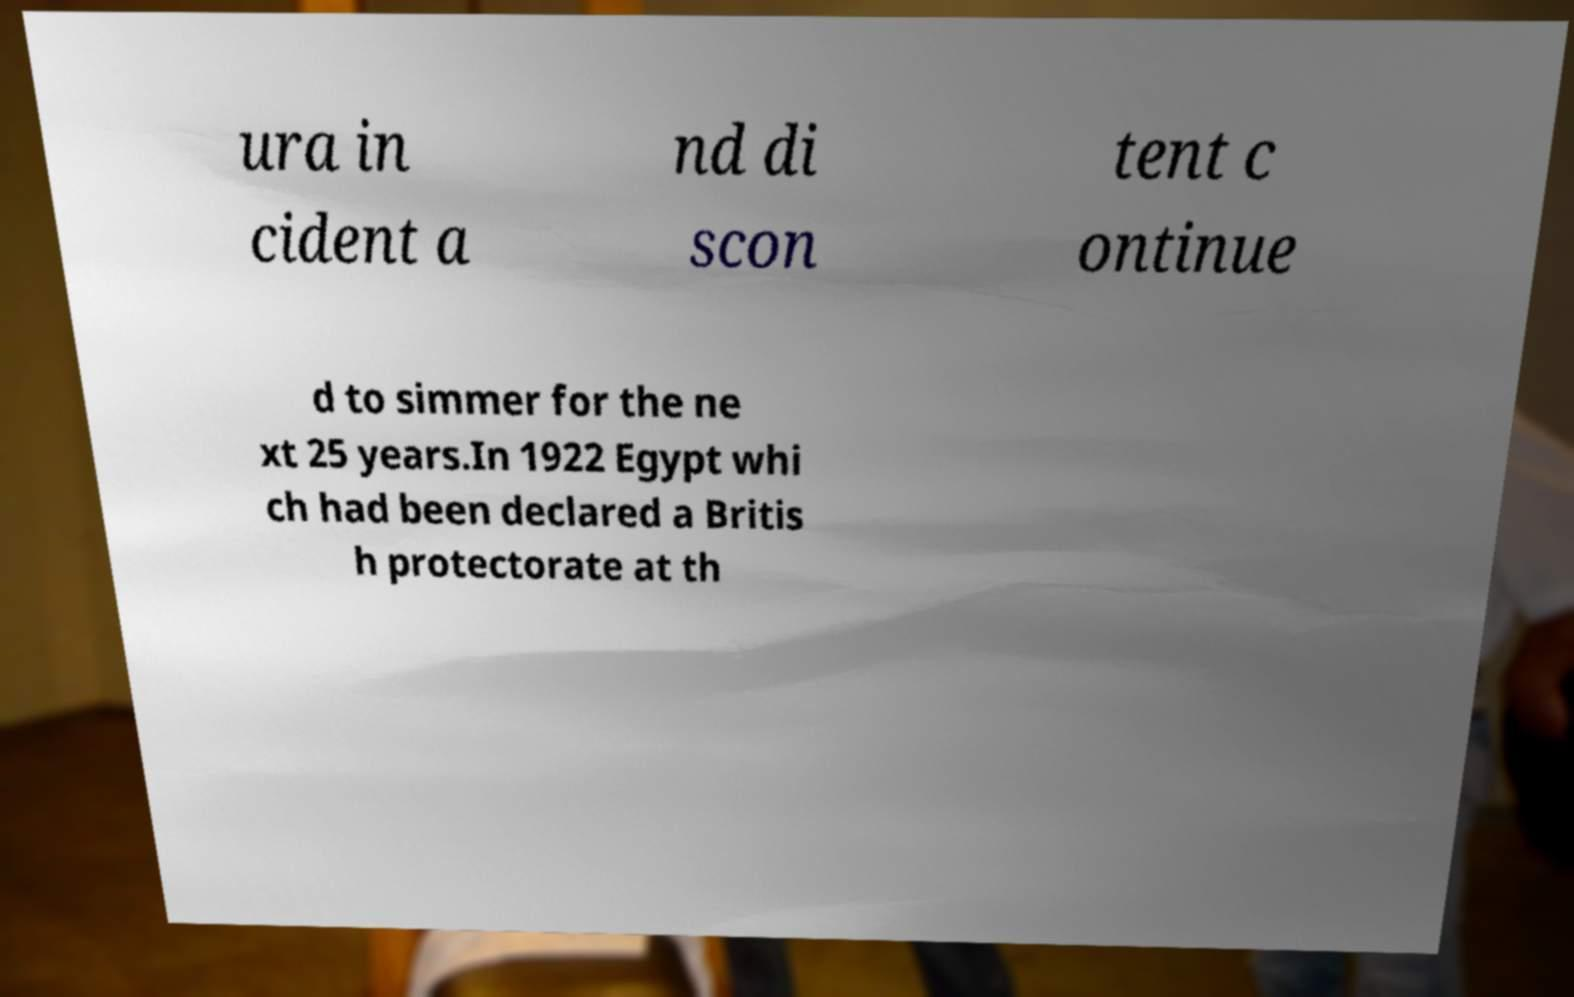For documentation purposes, I need the text within this image transcribed. Could you provide that? ura in cident a nd di scon tent c ontinue d to simmer for the ne xt 25 years.In 1922 Egypt whi ch had been declared a Britis h protectorate at th 